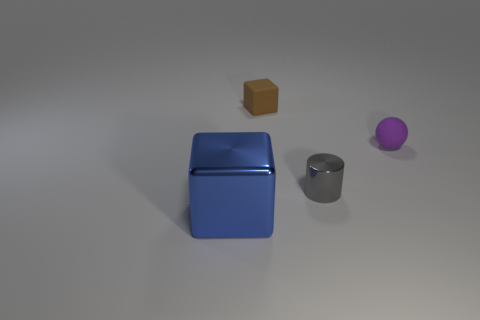Add 1 big balls. How many objects exist? 5 Subtract all cylinders. How many objects are left? 3 Subtract all large yellow matte cubes. Subtract all tiny brown cubes. How many objects are left? 3 Add 3 small matte things. How many small matte things are left? 5 Add 4 small gray cylinders. How many small gray cylinders exist? 5 Subtract 0 green cylinders. How many objects are left? 4 